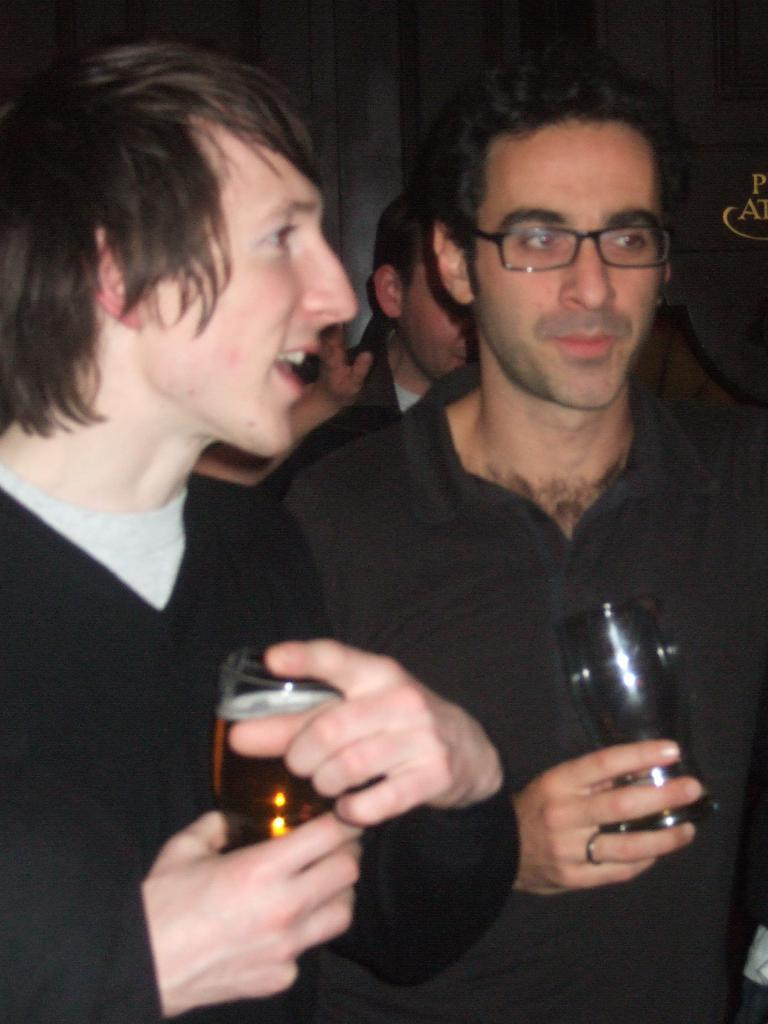How many people are visible in the image? There are two people standing in the image. What are the two people holding in their hands? The two people are holding glasses in their hands. Is there anyone else visible in the image besides the two people? Yes, there is a person standing in the background of the image. What type of prison can be seen in the background of the image? There is no prison present in the image; it only features the two people holding glasses and a person standing in the background. 